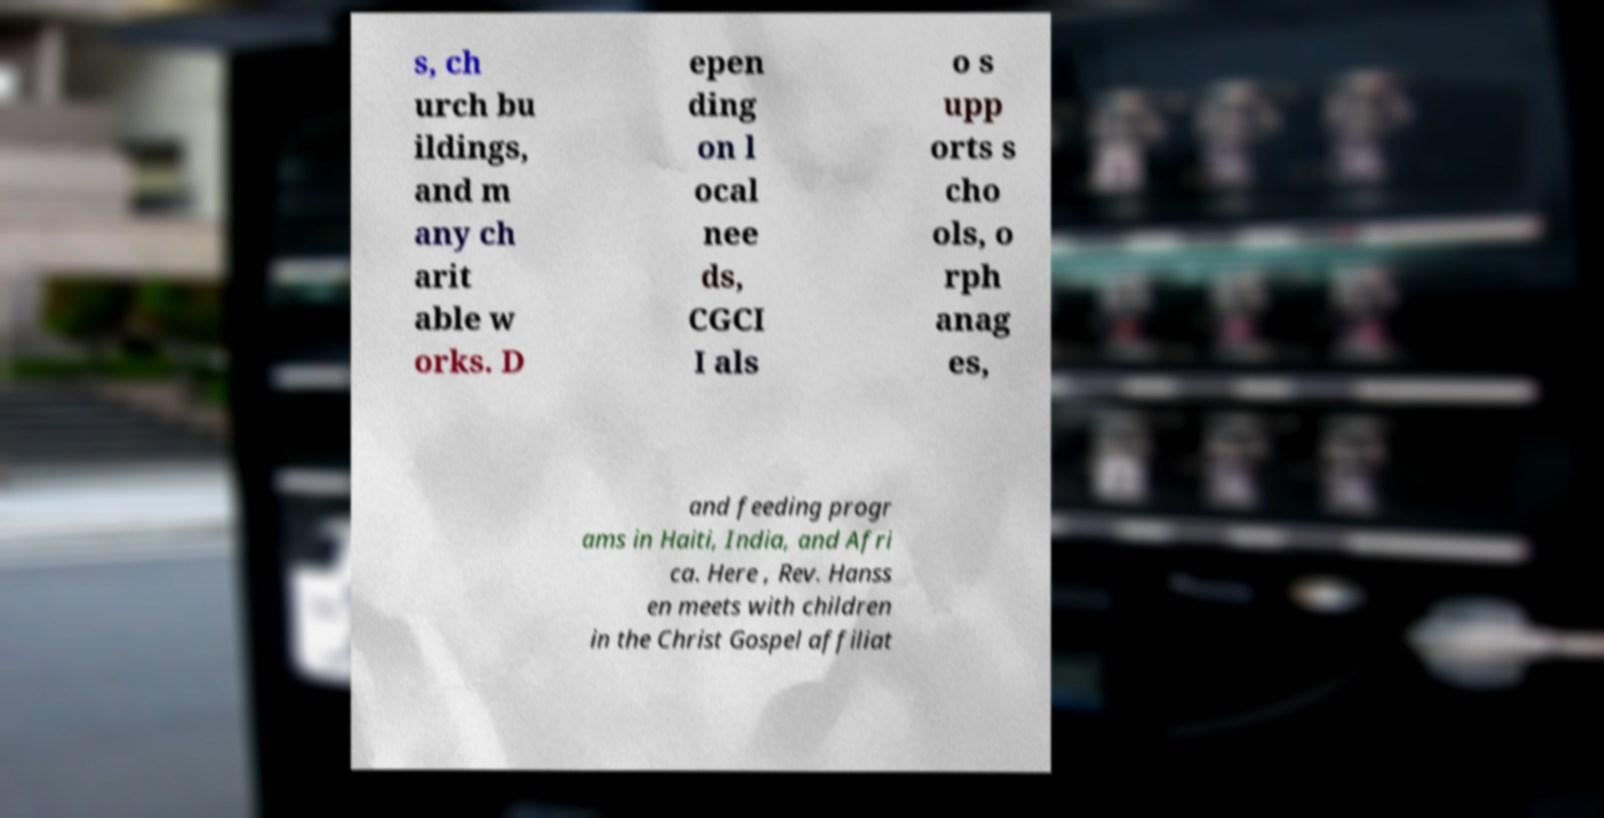I need the written content from this picture converted into text. Can you do that? s, ch urch bu ildings, and m any ch arit able w orks. D epen ding on l ocal nee ds, CGCI I als o s upp orts s cho ols, o rph anag es, and feeding progr ams in Haiti, India, and Afri ca. Here , Rev. Hanss en meets with children in the Christ Gospel affiliat 